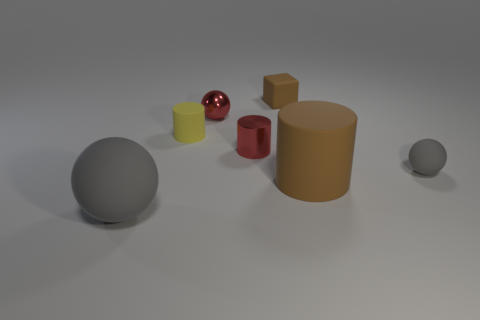Can you guess the material of the objects purely based on their appearance? The objects seem to be made of different materials. The shiny ones likely represent metals or plastics with a high-gloss finish, while the matte surfaces suggest a rubber-like material, which is distinct in its light-absorbing quality. 